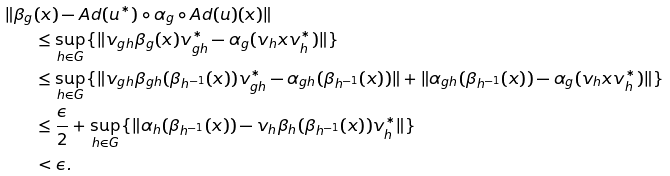<formula> <loc_0><loc_0><loc_500><loc_500>\| \beta _ { g } & ( x ) - A d ( u ^ { * } ) \circ \alpha _ { g } \circ A d ( u ) ( x ) \| \\ & \leq \sup _ { h \in G } \{ \| v _ { g h } \beta _ { g } ( x ) v _ { g h } ^ { * } - \alpha _ { g } ( v _ { h } x v _ { h } ^ { * } ) \| \} \\ & \leq \sup _ { h \in G } \{ \| v _ { g h } \beta _ { g h } ( \beta _ { h ^ { - 1 } } ( x ) ) v _ { g h } ^ { * } - \alpha _ { g h } ( \beta _ { h ^ { - 1 } } ( x ) ) \| + \| \alpha _ { g h } ( \beta _ { h ^ { - 1 } } ( x ) ) - \alpha _ { g } ( v _ { h } x v _ { h } ^ { * } ) \| \} \\ & \leq \frac { \epsilon } { 2 } + \sup _ { h \in G } \{ \| \alpha _ { h } ( \beta _ { h ^ { - 1 } } ( x ) ) - v _ { h } \beta _ { h } ( \beta _ { h ^ { - 1 } } ( x ) ) v _ { h } ^ { * } \| \} \\ & < \epsilon .</formula> 